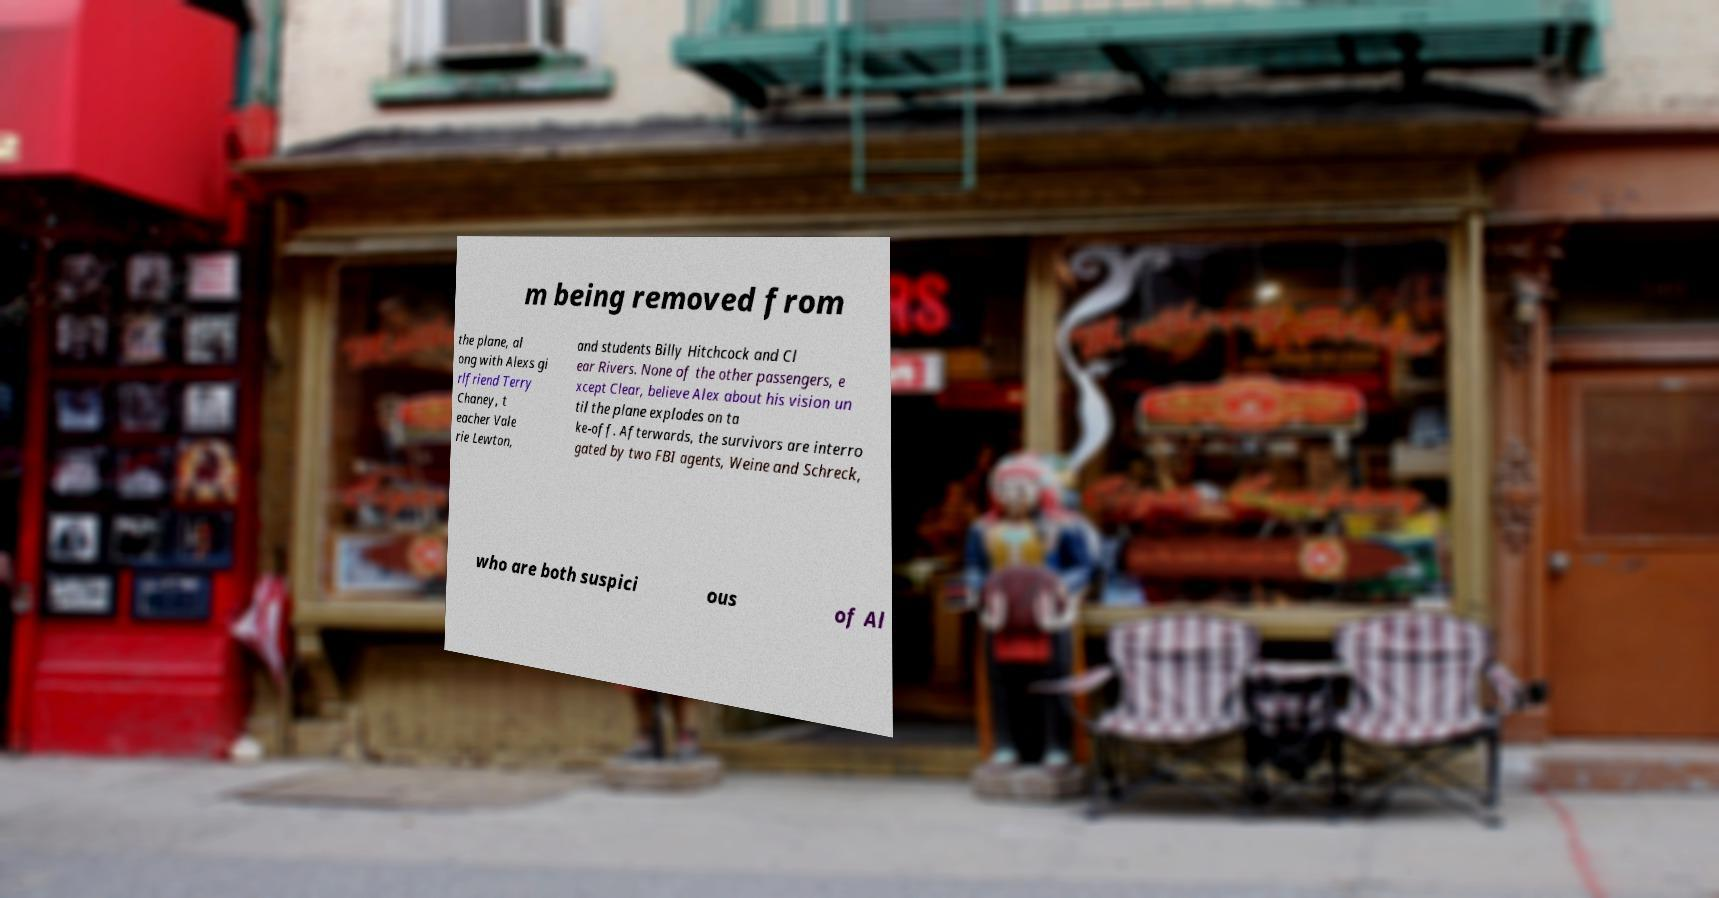I need the written content from this picture converted into text. Can you do that? m being removed from the plane, al ong with Alexs gi rlfriend Terry Chaney, t eacher Vale rie Lewton, and students Billy Hitchcock and Cl ear Rivers. None of the other passengers, e xcept Clear, believe Alex about his vision un til the plane explodes on ta ke-off. Afterwards, the survivors are interro gated by two FBI agents, Weine and Schreck, who are both suspici ous of Al 